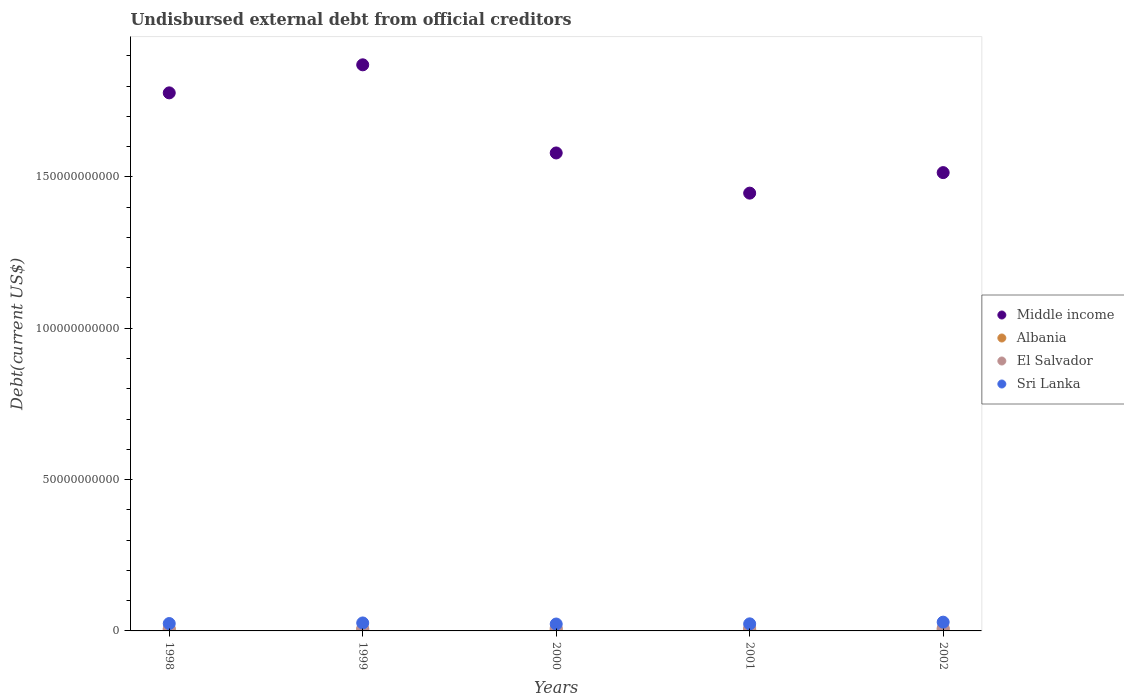Is the number of dotlines equal to the number of legend labels?
Ensure brevity in your answer.  Yes. What is the total debt in Middle income in 1998?
Keep it short and to the point. 1.78e+11. Across all years, what is the maximum total debt in Middle income?
Offer a terse response. 1.87e+11. Across all years, what is the minimum total debt in El Salvador?
Your response must be concise. 7.89e+08. What is the total total debt in El Salvador in the graph?
Keep it short and to the point. 4.52e+09. What is the difference between the total debt in El Salvador in 2001 and that in 2002?
Provide a succinct answer. 2.39e+07. What is the difference between the total debt in El Salvador in 1999 and the total debt in Middle income in 2000?
Offer a terse response. -1.57e+11. What is the average total debt in Middle income per year?
Your answer should be compact. 1.64e+11. In the year 1998, what is the difference between the total debt in Sri Lanka and total debt in El Salvador?
Make the answer very short. 1.65e+09. What is the ratio of the total debt in Middle income in 1998 to that in 2002?
Give a very brief answer. 1.17. Is the total debt in Sri Lanka in 1998 less than that in 1999?
Your answer should be very brief. Yes. Is the difference between the total debt in Sri Lanka in 1999 and 2001 greater than the difference between the total debt in El Salvador in 1999 and 2001?
Ensure brevity in your answer.  Yes. What is the difference between the highest and the second highest total debt in El Salvador?
Offer a very short reply. 2.10e+06. What is the difference between the highest and the lowest total debt in Sri Lanka?
Make the answer very short. 6.16e+08. Are the values on the major ticks of Y-axis written in scientific E-notation?
Make the answer very short. No. Does the graph contain any zero values?
Give a very brief answer. No. Does the graph contain grids?
Provide a succinct answer. No. How many legend labels are there?
Ensure brevity in your answer.  4. What is the title of the graph?
Give a very brief answer. Undisbursed external debt from official creditors. Does "Guatemala" appear as one of the legend labels in the graph?
Ensure brevity in your answer.  No. What is the label or title of the X-axis?
Your answer should be very brief. Years. What is the label or title of the Y-axis?
Keep it short and to the point. Debt(current US$). What is the Debt(current US$) of Middle income in 1998?
Offer a very short reply. 1.78e+11. What is the Debt(current US$) in Albania in 1998?
Your response must be concise. 4.28e+08. What is the Debt(current US$) in El Salvador in 1998?
Provide a short and direct response. 7.89e+08. What is the Debt(current US$) in Sri Lanka in 1998?
Your response must be concise. 2.44e+09. What is the Debt(current US$) in Middle income in 1999?
Your answer should be compact. 1.87e+11. What is the Debt(current US$) of Albania in 1999?
Offer a very short reply. 4.67e+08. What is the Debt(current US$) in El Salvador in 1999?
Your answer should be very brief. 8.08e+08. What is the Debt(current US$) in Sri Lanka in 1999?
Provide a short and direct response. 2.63e+09. What is the Debt(current US$) in Middle income in 2000?
Ensure brevity in your answer.  1.58e+11. What is the Debt(current US$) of Albania in 2000?
Your response must be concise. 4.57e+08. What is the Debt(current US$) of El Salvador in 2000?
Keep it short and to the point. 9.84e+08. What is the Debt(current US$) of Sri Lanka in 2000?
Give a very brief answer. 2.28e+09. What is the Debt(current US$) in Middle income in 2001?
Provide a short and direct response. 1.45e+11. What is the Debt(current US$) of Albania in 2001?
Offer a very short reply. 4.41e+08. What is the Debt(current US$) of El Salvador in 2001?
Give a very brief answer. 9.82e+08. What is the Debt(current US$) of Sri Lanka in 2001?
Offer a terse response. 2.34e+09. What is the Debt(current US$) of Middle income in 2002?
Your response must be concise. 1.51e+11. What is the Debt(current US$) of Albania in 2002?
Make the answer very short. 5.32e+08. What is the Debt(current US$) of El Salvador in 2002?
Your answer should be compact. 9.58e+08. What is the Debt(current US$) in Sri Lanka in 2002?
Your answer should be compact. 2.89e+09. Across all years, what is the maximum Debt(current US$) in Middle income?
Give a very brief answer. 1.87e+11. Across all years, what is the maximum Debt(current US$) of Albania?
Make the answer very short. 5.32e+08. Across all years, what is the maximum Debt(current US$) in El Salvador?
Your answer should be very brief. 9.84e+08. Across all years, what is the maximum Debt(current US$) in Sri Lanka?
Ensure brevity in your answer.  2.89e+09. Across all years, what is the minimum Debt(current US$) of Middle income?
Make the answer very short. 1.45e+11. Across all years, what is the minimum Debt(current US$) of Albania?
Make the answer very short. 4.28e+08. Across all years, what is the minimum Debt(current US$) of El Salvador?
Your answer should be compact. 7.89e+08. Across all years, what is the minimum Debt(current US$) in Sri Lanka?
Offer a very short reply. 2.28e+09. What is the total Debt(current US$) of Middle income in the graph?
Offer a terse response. 8.19e+11. What is the total Debt(current US$) of Albania in the graph?
Ensure brevity in your answer.  2.32e+09. What is the total Debt(current US$) in El Salvador in the graph?
Provide a succinct answer. 4.52e+09. What is the total Debt(current US$) in Sri Lanka in the graph?
Ensure brevity in your answer.  1.26e+1. What is the difference between the Debt(current US$) in Middle income in 1998 and that in 1999?
Your answer should be very brief. -9.27e+09. What is the difference between the Debt(current US$) of Albania in 1998 and that in 1999?
Keep it short and to the point. -3.95e+07. What is the difference between the Debt(current US$) in El Salvador in 1998 and that in 1999?
Offer a very short reply. -1.84e+07. What is the difference between the Debt(current US$) of Sri Lanka in 1998 and that in 1999?
Provide a short and direct response. -1.96e+08. What is the difference between the Debt(current US$) of Middle income in 1998 and that in 2000?
Ensure brevity in your answer.  1.99e+1. What is the difference between the Debt(current US$) in Albania in 1998 and that in 2000?
Keep it short and to the point. -2.88e+07. What is the difference between the Debt(current US$) of El Salvador in 1998 and that in 2000?
Your answer should be compact. -1.94e+08. What is the difference between the Debt(current US$) in Sri Lanka in 1998 and that in 2000?
Make the answer very short. 1.59e+08. What is the difference between the Debt(current US$) of Middle income in 1998 and that in 2001?
Offer a very short reply. 3.31e+1. What is the difference between the Debt(current US$) in Albania in 1998 and that in 2001?
Offer a very short reply. -1.28e+07. What is the difference between the Debt(current US$) in El Salvador in 1998 and that in 2001?
Ensure brevity in your answer.  -1.92e+08. What is the difference between the Debt(current US$) in Sri Lanka in 1998 and that in 2001?
Offer a very short reply. 9.97e+07. What is the difference between the Debt(current US$) in Middle income in 1998 and that in 2002?
Offer a very short reply. 2.63e+1. What is the difference between the Debt(current US$) in Albania in 1998 and that in 2002?
Offer a terse response. -1.04e+08. What is the difference between the Debt(current US$) of El Salvador in 1998 and that in 2002?
Keep it short and to the point. -1.68e+08. What is the difference between the Debt(current US$) of Sri Lanka in 1998 and that in 2002?
Make the answer very short. -4.57e+08. What is the difference between the Debt(current US$) of Middle income in 1999 and that in 2000?
Your answer should be very brief. 2.91e+1. What is the difference between the Debt(current US$) of Albania in 1999 and that in 2000?
Offer a terse response. 1.07e+07. What is the difference between the Debt(current US$) of El Salvador in 1999 and that in 2000?
Your response must be concise. -1.76e+08. What is the difference between the Debt(current US$) in Sri Lanka in 1999 and that in 2000?
Make the answer very short. 3.55e+08. What is the difference between the Debt(current US$) in Middle income in 1999 and that in 2001?
Offer a very short reply. 4.24e+1. What is the difference between the Debt(current US$) in Albania in 1999 and that in 2001?
Keep it short and to the point. 2.67e+07. What is the difference between the Debt(current US$) of El Salvador in 1999 and that in 2001?
Give a very brief answer. -1.74e+08. What is the difference between the Debt(current US$) of Sri Lanka in 1999 and that in 2001?
Offer a very short reply. 2.96e+08. What is the difference between the Debt(current US$) of Middle income in 1999 and that in 2002?
Make the answer very short. 3.56e+1. What is the difference between the Debt(current US$) in Albania in 1999 and that in 2002?
Provide a succinct answer. -6.49e+07. What is the difference between the Debt(current US$) of El Salvador in 1999 and that in 2002?
Provide a short and direct response. -1.50e+08. What is the difference between the Debt(current US$) in Sri Lanka in 1999 and that in 2002?
Make the answer very short. -2.60e+08. What is the difference between the Debt(current US$) in Middle income in 2000 and that in 2001?
Your answer should be very brief. 1.33e+1. What is the difference between the Debt(current US$) in Albania in 2000 and that in 2001?
Offer a very short reply. 1.60e+07. What is the difference between the Debt(current US$) of El Salvador in 2000 and that in 2001?
Your answer should be compact. 2.10e+06. What is the difference between the Debt(current US$) of Sri Lanka in 2000 and that in 2001?
Give a very brief answer. -5.93e+07. What is the difference between the Debt(current US$) of Middle income in 2000 and that in 2002?
Your response must be concise. 6.49e+09. What is the difference between the Debt(current US$) of Albania in 2000 and that in 2002?
Keep it short and to the point. -7.56e+07. What is the difference between the Debt(current US$) in El Salvador in 2000 and that in 2002?
Give a very brief answer. 2.60e+07. What is the difference between the Debt(current US$) of Sri Lanka in 2000 and that in 2002?
Your answer should be compact. -6.16e+08. What is the difference between the Debt(current US$) of Middle income in 2001 and that in 2002?
Offer a very short reply. -6.78e+09. What is the difference between the Debt(current US$) in Albania in 2001 and that in 2002?
Ensure brevity in your answer.  -9.16e+07. What is the difference between the Debt(current US$) of El Salvador in 2001 and that in 2002?
Your answer should be very brief. 2.39e+07. What is the difference between the Debt(current US$) in Sri Lanka in 2001 and that in 2002?
Offer a terse response. -5.56e+08. What is the difference between the Debt(current US$) of Middle income in 1998 and the Debt(current US$) of Albania in 1999?
Give a very brief answer. 1.77e+11. What is the difference between the Debt(current US$) of Middle income in 1998 and the Debt(current US$) of El Salvador in 1999?
Ensure brevity in your answer.  1.77e+11. What is the difference between the Debt(current US$) of Middle income in 1998 and the Debt(current US$) of Sri Lanka in 1999?
Provide a short and direct response. 1.75e+11. What is the difference between the Debt(current US$) in Albania in 1998 and the Debt(current US$) in El Salvador in 1999?
Keep it short and to the point. -3.80e+08. What is the difference between the Debt(current US$) of Albania in 1998 and the Debt(current US$) of Sri Lanka in 1999?
Provide a succinct answer. -2.21e+09. What is the difference between the Debt(current US$) of El Salvador in 1998 and the Debt(current US$) of Sri Lanka in 1999?
Offer a terse response. -1.84e+09. What is the difference between the Debt(current US$) in Middle income in 1998 and the Debt(current US$) in Albania in 2000?
Make the answer very short. 1.77e+11. What is the difference between the Debt(current US$) in Middle income in 1998 and the Debt(current US$) in El Salvador in 2000?
Ensure brevity in your answer.  1.77e+11. What is the difference between the Debt(current US$) in Middle income in 1998 and the Debt(current US$) in Sri Lanka in 2000?
Give a very brief answer. 1.75e+11. What is the difference between the Debt(current US$) in Albania in 1998 and the Debt(current US$) in El Salvador in 2000?
Offer a terse response. -5.56e+08. What is the difference between the Debt(current US$) of Albania in 1998 and the Debt(current US$) of Sri Lanka in 2000?
Give a very brief answer. -1.85e+09. What is the difference between the Debt(current US$) of El Salvador in 1998 and the Debt(current US$) of Sri Lanka in 2000?
Give a very brief answer. -1.49e+09. What is the difference between the Debt(current US$) in Middle income in 1998 and the Debt(current US$) in Albania in 2001?
Keep it short and to the point. 1.77e+11. What is the difference between the Debt(current US$) in Middle income in 1998 and the Debt(current US$) in El Salvador in 2001?
Provide a succinct answer. 1.77e+11. What is the difference between the Debt(current US$) of Middle income in 1998 and the Debt(current US$) of Sri Lanka in 2001?
Your answer should be very brief. 1.75e+11. What is the difference between the Debt(current US$) of Albania in 1998 and the Debt(current US$) of El Salvador in 2001?
Your answer should be compact. -5.54e+08. What is the difference between the Debt(current US$) of Albania in 1998 and the Debt(current US$) of Sri Lanka in 2001?
Your answer should be compact. -1.91e+09. What is the difference between the Debt(current US$) of El Salvador in 1998 and the Debt(current US$) of Sri Lanka in 2001?
Offer a terse response. -1.55e+09. What is the difference between the Debt(current US$) in Middle income in 1998 and the Debt(current US$) in Albania in 2002?
Ensure brevity in your answer.  1.77e+11. What is the difference between the Debt(current US$) of Middle income in 1998 and the Debt(current US$) of El Salvador in 2002?
Your answer should be compact. 1.77e+11. What is the difference between the Debt(current US$) of Middle income in 1998 and the Debt(current US$) of Sri Lanka in 2002?
Provide a short and direct response. 1.75e+11. What is the difference between the Debt(current US$) of Albania in 1998 and the Debt(current US$) of El Salvador in 2002?
Keep it short and to the point. -5.30e+08. What is the difference between the Debt(current US$) in Albania in 1998 and the Debt(current US$) in Sri Lanka in 2002?
Your response must be concise. -2.47e+09. What is the difference between the Debt(current US$) in El Salvador in 1998 and the Debt(current US$) in Sri Lanka in 2002?
Ensure brevity in your answer.  -2.10e+09. What is the difference between the Debt(current US$) in Middle income in 1999 and the Debt(current US$) in Albania in 2000?
Offer a terse response. 1.87e+11. What is the difference between the Debt(current US$) in Middle income in 1999 and the Debt(current US$) in El Salvador in 2000?
Ensure brevity in your answer.  1.86e+11. What is the difference between the Debt(current US$) in Middle income in 1999 and the Debt(current US$) in Sri Lanka in 2000?
Offer a terse response. 1.85e+11. What is the difference between the Debt(current US$) in Albania in 1999 and the Debt(current US$) in El Salvador in 2000?
Offer a terse response. -5.16e+08. What is the difference between the Debt(current US$) in Albania in 1999 and the Debt(current US$) in Sri Lanka in 2000?
Give a very brief answer. -1.81e+09. What is the difference between the Debt(current US$) in El Salvador in 1999 and the Debt(current US$) in Sri Lanka in 2000?
Offer a very short reply. -1.47e+09. What is the difference between the Debt(current US$) of Middle income in 1999 and the Debt(current US$) of Albania in 2001?
Offer a terse response. 1.87e+11. What is the difference between the Debt(current US$) of Middle income in 1999 and the Debt(current US$) of El Salvador in 2001?
Provide a short and direct response. 1.86e+11. What is the difference between the Debt(current US$) in Middle income in 1999 and the Debt(current US$) in Sri Lanka in 2001?
Your answer should be very brief. 1.85e+11. What is the difference between the Debt(current US$) of Albania in 1999 and the Debt(current US$) of El Salvador in 2001?
Your answer should be very brief. -5.14e+08. What is the difference between the Debt(current US$) in Albania in 1999 and the Debt(current US$) in Sri Lanka in 2001?
Provide a short and direct response. -1.87e+09. What is the difference between the Debt(current US$) in El Salvador in 1999 and the Debt(current US$) in Sri Lanka in 2001?
Keep it short and to the point. -1.53e+09. What is the difference between the Debt(current US$) of Middle income in 1999 and the Debt(current US$) of Albania in 2002?
Offer a very short reply. 1.86e+11. What is the difference between the Debt(current US$) in Middle income in 1999 and the Debt(current US$) in El Salvador in 2002?
Ensure brevity in your answer.  1.86e+11. What is the difference between the Debt(current US$) of Middle income in 1999 and the Debt(current US$) of Sri Lanka in 2002?
Your response must be concise. 1.84e+11. What is the difference between the Debt(current US$) in Albania in 1999 and the Debt(current US$) in El Salvador in 2002?
Offer a very short reply. -4.90e+08. What is the difference between the Debt(current US$) in Albania in 1999 and the Debt(current US$) in Sri Lanka in 2002?
Provide a short and direct response. -2.43e+09. What is the difference between the Debt(current US$) in El Salvador in 1999 and the Debt(current US$) in Sri Lanka in 2002?
Offer a very short reply. -2.09e+09. What is the difference between the Debt(current US$) in Middle income in 2000 and the Debt(current US$) in Albania in 2001?
Provide a short and direct response. 1.57e+11. What is the difference between the Debt(current US$) in Middle income in 2000 and the Debt(current US$) in El Salvador in 2001?
Offer a terse response. 1.57e+11. What is the difference between the Debt(current US$) of Middle income in 2000 and the Debt(current US$) of Sri Lanka in 2001?
Make the answer very short. 1.56e+11. What is the difference between the Debt(current US$) in Albania in 2000 and the Debt(current US$) in El Salvador in 2001?
Offer a very short reply. -5.25e+08. What is the difference between the Debt(current US$) in Albania in 2000 and the Debt(current US$) in Sri Lanka in 2001?
Keep it short and to the point. -1.88e+09. What is the difference between the Debt(current US$) in El Salvador in 2000 and the Debt(current US$) in Sri Lanka in 2001?
Make the answer very short. -1.35e+09. What is the difference between the Debt(current US$) of Middle income in 2000 and the Debt(current US$) of Albania in 2002?
Your answer should be very brief. 1.57e+11. What is the difference between the Debt(current US$) in Middle income in 2000 and the Debt(current US$) in El Salvador in 2002?
Your response must be concise. 1.57e+11. What is the difference between the Debt(current US$) in Middle income in 2000 and the Debt(current US$) in Sri Lanka in 2002?
Provide a succinct answer. 1.55e+11. What is the difference between the Debt(current US$) in Albania in 2000 and the Debt(current US$) in El Salvador in 2002?
Your response must be concise. -5.01e+08. What is the difference between the Debt(current US$) in Albania in 2000 and the Debt(current US$) in Sri Lanka in 2002?
Provide a succinct answer. -2.44e+09. What is the difference between the Debt(current US$) in El Salvador in 2000 and the Debt(current US$) in Sri Lanka in 2002?
Your response must be concise. -1.91e+09. What is the difference between the Debt(current US$) of Middle income in 2001 and the Debt(current US$) of Albania in 2002?
Your answer should be very brief. 1.44e+11. What is the difference between the Debt(current US$) in Middle income in 2001 and the Debt(current US$) in El Salvador in 2002?
Your answer should be very brief. 1.44e+11. What is the difference between the Debt(current US$) in Middle income in 2001 and the Debt(current US$) in Sri Lanka in 2002?
Your answer should be very brief. 1.42e+11. What is the difference between the Debt(current US$) of Albania in 2001 and the Debt(current US$) of El Salvador in 2002?
Your response must be concise. -5.17e+08. What is the difference between the Debt(current US$) of Albania in 2001 and the Debt(current US$) of Sri Lanka in 2002?
Keep it short and to the point. -2.45e+09. What is the difference between the Debt(current US$) of El Salvador in 2001 and the Debt(current US$) of Sri Lanka in 2002?
Your response must be concise. -1.91e+09. What is the average Debt(current US$) in Middle income per year?
Your answer should be very brief. 1.64e+11. What is the average Debt(current US$) of Albania per year?
Make the answer very short. 4.65e+08. What is the average Debt(current US$) of El Salvador per year?
Provide a short and direct response. 9.04e+08. What is the average Debt(current US$) of Sri Lanka per year?
Provide a succinct answer. 2.52e+09. In the year 1998, what is the difference between the Debt(current US$) in Middle income and Debt(current US$) in Albania?
Give a very brief answer. 1.77e+11. In the year 1998, what is the difference between the Debt(current US$) in Middle income and Debt(current US$) in El Salvador?
Your response must be concise. 1.77e+11. In the year 1998, what is the difference between the Debt(current US$) in Middle income and Debt(current US$) in Sri Lanka?
Offer a very short reply. 1.75e+11. In the year 1998, what is the difference between the Debt(current US$) in Albania and Debt(current US$) in El Salvador?
Provide a succinct answer. -3.62e+08. In the year 1998, what is the difference between the Debt(current US$) of Albania and Debt(current US$) of Sri Lanka?
Your answer should be very brief. -2.01e+09. In the year 1998, what is the difference between the Debt(current US$) of El Salvador and Debt(current US$) of Sri Lanka?
Provide a succinct answer. -1.65e+09. In the year 1999, what is the difference between the Debt(current US$) in Middle income and Debt(current US$) in Albania?
Keep it short and to the point. 1.87e+11. In the year 1999, what is the difference between the Debt(current US$) in Middle income and Debt(current US$) in El Salvador?
Your answer should be compact. 1.86e+11. In the year 1999, what is the difference between the Debt(current US$) of Middle income and Debt(current US$) of Sri Lanka?
Provide a succinct answer. 1.84e+11. In the year 1999, what is the difference between the Debt(current US$) of Albania and Debt(current US$) of El Salvador?
Offer a very short reply. -3.40e+08. In the year 1999, what is the difference between the Debt(current US$) in Albania and Debt(current US$) in Sri Lanka?
Keep it short and to the point. -2.17e+09. In the year 1999, what is the difference between the Debt(current US$) in El Salvador and Debt(current US$) in Sri Lanka?
Offer a terse response. -1.83e+09. In the year 2000, what is the difference between the Debt(current US$) of Middle income and Debt(current US$) of Albania?
Your response must be concise. 1.57e+11. In the year 2000, what is the difference between the Debt(current US$) in Middle income and Debt(current US$) in El Salvador?
Your answer should be very brief. 1.57e+11. In the year 2000, what is the difference between the Debt(current US$) of Middle income and Debt(current US$) of Sri Lanka?
Offer a terse response. 1.56e+11. In the year 2000, what is the difference between the Debt(current US$) of Albania and Debt(current US$) of El Salvador?
Offer a terse response. -5.27e+08. In the year 2000, what is the difference between the Debt(current US$) in Albania and Debt(current US$) in Sri Lanka?
Ensure brevity in your answer.  -1.82e+09. In the year 2000, what is the difference between the Debt(current US$) of El Salvador and Debt(current US$) of Sri Lanka?
Provide a succinct answer. -1.29e+09. In the year 2001, what is the difference between the Debt(current US$) of Middle income and Debt(current US$) of Albania?
Your answer should be compact. 1.44e+11. In the year 2001, what is the difference between the Debt(current US$) of Middle income and Debt(current US$) of El Salvador?
Provide a succinct answer. 1.44e+11. In the year 2001, what is the difference between the Debt(current US$) of Middle income and Debt(current US$) of Sri Lanka?
Provide a short and direct response. 1.42e+11. In the year 2001, what is the difference between the Debt(current US$) in Albania and Debt(current US$) in El Salvador?
Provide a short and direct response. -5.41e+08. In the year 2001, what is the difference between the Debt(current US$) of Albania and Debt(current US$) of Sri Lanka?
Offer a very short reply. -1.90e+09. In the year 2001, what is the difference between the Debt(current US$) in El Salvador and Debt(current US$) in Sri Lanka?
Offer a very short reply. -1.36e+09. In the year 2002, what is the difference between the Debt(current US$) of Middle income and Debt(current US$) of Albania?
Make the answer very short. 1.51e+11. In the year 2002, what is the difference between the Debt(current US$) of Middle income and Debt(current US$) of El Salvador?
Provide a succinct answer. 1.50e+11. In the year 2002, what is the difference between the Debt(current US$) of Middle income and Debt(current US$) of Sri Lanka?
Offer a terse response. 1.49e+11. In the year 2002, what is the difference between the Debt(current US$) of Albania and Debt(current US$) of El Salvador?
Your response must be concise. -4.25e+08. In the year 2002, what is the difference between the Debt(current US$) of Albania and Debt(current US$) of Sri Lanka?
Offer a terse response. -2.36e+09. In the year 2002, what is the difference between the Debt(current US$) of El Salvador and Debt(current US$) of Sri Lanka?
Make the answer very short. -1.94e+09. What is the ratio of the Debt(current US$) of Middle income in 1998 to that in 1999?
Offer a very short reply. 0.95. What is the ratio of the Debt(current US$) of Albania in 1998 to that in 1999?
Your answer should be compact. 0.92. What is the ratio of the Debt(current US$) in El Salvador in 1998 to that in 1999?
Provide a short and direct response. 0.98. What is the ratio of the Debt(current US$) in Sri Lanka in 1998 to that in 1999?
Ensure brevity in your answer.  0.93. What is the ratio of the Debt(current US$) in Middle income in 1998 to that in 2000?
Your response must be concise. 1.13. What is the ratio of the Debt(current US$) in Albania in 1998 to that in 2000?
Provide a short and direct response. 0.94. What is the ratio of the Debt(current US$) in El Salvador in 1998 to that in 2000?
Offer a very short reply. 0.8. What is the ratio of the Debt(current US$) of Sri Lanka in 1998 to that in 2000?
Provide a short and direct response. 1.07. What is the ratio of the Debt(current US$) of Middle income in 1998 to that in 2001?
Offer a terse response. 1.23. What is the ratio of the Debt(current US$) of Albania in 1998 to that in 2001?
Your response must be concise. 0.97. What is the ratio of the Debt(current US$) of El Salvador in 1998 to that in 2001?
Your answer should be compact. 0.8. What is the ratio of the Debt(current US$) of Sri Lanka in 1998 to that in 2001?
Your answer should be very brief. 1.04. What is the ratio of the Debt(current US$) of Middle income in 1998 to that in 2002?
Your response must be concise. 1.17. What is the ratio of the Debt(current US$) of Albania in 1998 to that in 2002?
Provide a succinct answer. 0.8. What is the ratio of the Debt(current US$) in El Salvador in 1998 to that in 2002?
Offer a very short reply. 0.82. What is the ratio of the Debt(current US$) of Sri Lanka in 1998 to that in 2002?
Ensure brevity in your answer.  0.84. What is the ratio of the Debt(current US$) in Middle income in 1999 to that in 2000?
Your answer should be very brief. 1.18. What is the ratio of the Debt(current US$) of Albania in 1999 to that in 2000?
Ensure brevity in your answer.  1.02. What is the ratio of the Debt(current US$) of El Salvador in 1999 to that in 2000?
Provide a short and direct response. 0.82. What is the ratio of the Debt(current US$) in Sri Lanka in 1999 to that in 2000?
Your answer should be very brief. 1.16. What is the ratio of the Debt(current US$) of Middle income in 1999 to that in 2001?
Offer a very short reply. 1.29. What is the ratio of the Debt(current US$) of Albania in 1999 to that in 2001?
Your answer should be very brief. 1.06. What is the ratio of the Debt(current US$) in El Salvador in 1999 to that in 2001?
Offer a very short reply. 0.82. What is the ratio of the Debt(current US$) in Sri Lanka in 1999 to that in 2001?
Ensure brevity in your answer.  1.13. What is the ratio of the Debt(current US$) of Middle income in 1999 to that in 2002?
Offer a very short reply. 1.24. What is the ratio of the Debt(current US$) of Albania in 1999 to that in 2002?
Your response must be concise. 0.88. What is the ratio of the Debt(current US$) of El Salvador in 1999 to that in 2002?
Offer a very short reply. 0.84. What is the ratio of the Debt(current US$) in Sri Lanka in 1999 to that in 2002?
Offer a very short reply. 0.91. What is the ratio of the Debt(current US$) of Middle income in 2000 to that in 2001?
Provide a succinct answer. 1.09. What is the ratio of the Debt(current US$) of Albania in 2000 to that in 2001?
Your answer should be very brief. 1.04. What is the ratio of the Debt(current US$) of El Salvador in 2000 to that in 2001?
Your answer should be very brief. 1. What is the ratio of the Debt(current US$) in Sri Lanka in 2000 to that in 2001?
Make the answer very short. 0.97. What is the ratio of the Debt(current US$) of Middle income in 2000 to that in 2002?
Ensure brevity in your answer.  1.04. What is the ratio of the Debt(current US$) of Albania in 2000 to that in 2002?
Keep it short and to the point. 0.86. What is the ratio of the Debt(current US$) in El Salvador in 2000 to that in 2002?
Provide a succinct answer. 1.03. What is the ratio of the Debt(current US$) of Sri Lanka in 2000 to that in 2002?
Ensure brevity in your answer.  0.79. What is the ratio of the Debt(current US$) in Middle income in 2001 to that in 2002?
Keep it short and to the point. 0.96. What is the ratio of the Debt(current US$) of Albania in 2001 to that in 2002?
Your answer should be very brief. 0.83. What is the ratio of the Debt(current US$) of Sri Lanka in 2001 to that in 2002?
Your answer should be very brief. 0.81. What is the difference between the highest and the second highest Debt(current US$) of Middle income?
Keep it short and to the point. 9.27e+09. What is the difference between the highest and the second highest Debt(current US$) in Albania?
Offer a very short reply. 6.49e+07. What is the difference between the highest and the second highest Debt(current US$) in El Salvador?
Offer a terse response. 2.10e+06. What is the difference between the highest and the second highest Debt(current US$) of Sri Lanka?
Offer a very short reply. 2.60e+08. What is the difference between the highest and the lowest Debt(current US$) of Middle income?
Provide a succinct answer. 4.24e+1. What is the difference between the highest and the lowest Debt(current US$) of Albania?
Your response must be concise. 1.04e+08. What is the difference between the highest and the lowest Debt(current US$) of El Salvador?
Provide a short and direct response. 1.94e+08. What is the difference between the highest and the lowest Debt(current US$) in Sri Lanka?
Your answer should be very brief. 6.16e+08. 